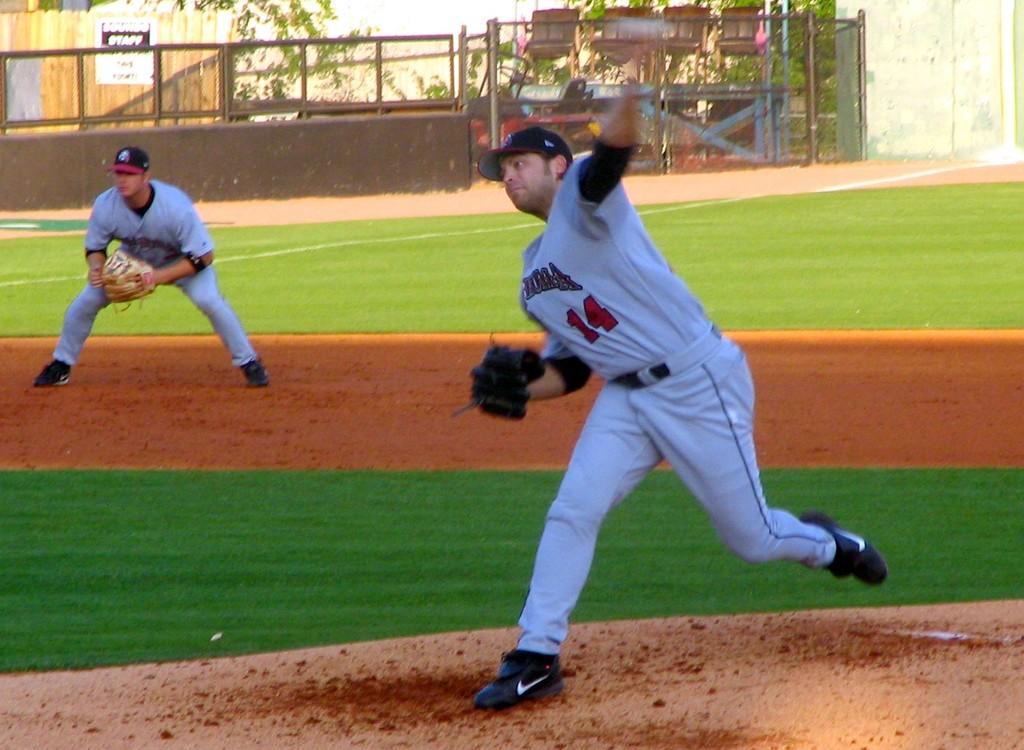What word is posted just above the top of the fence on the left side?
Your answer should be compact. Staff. 